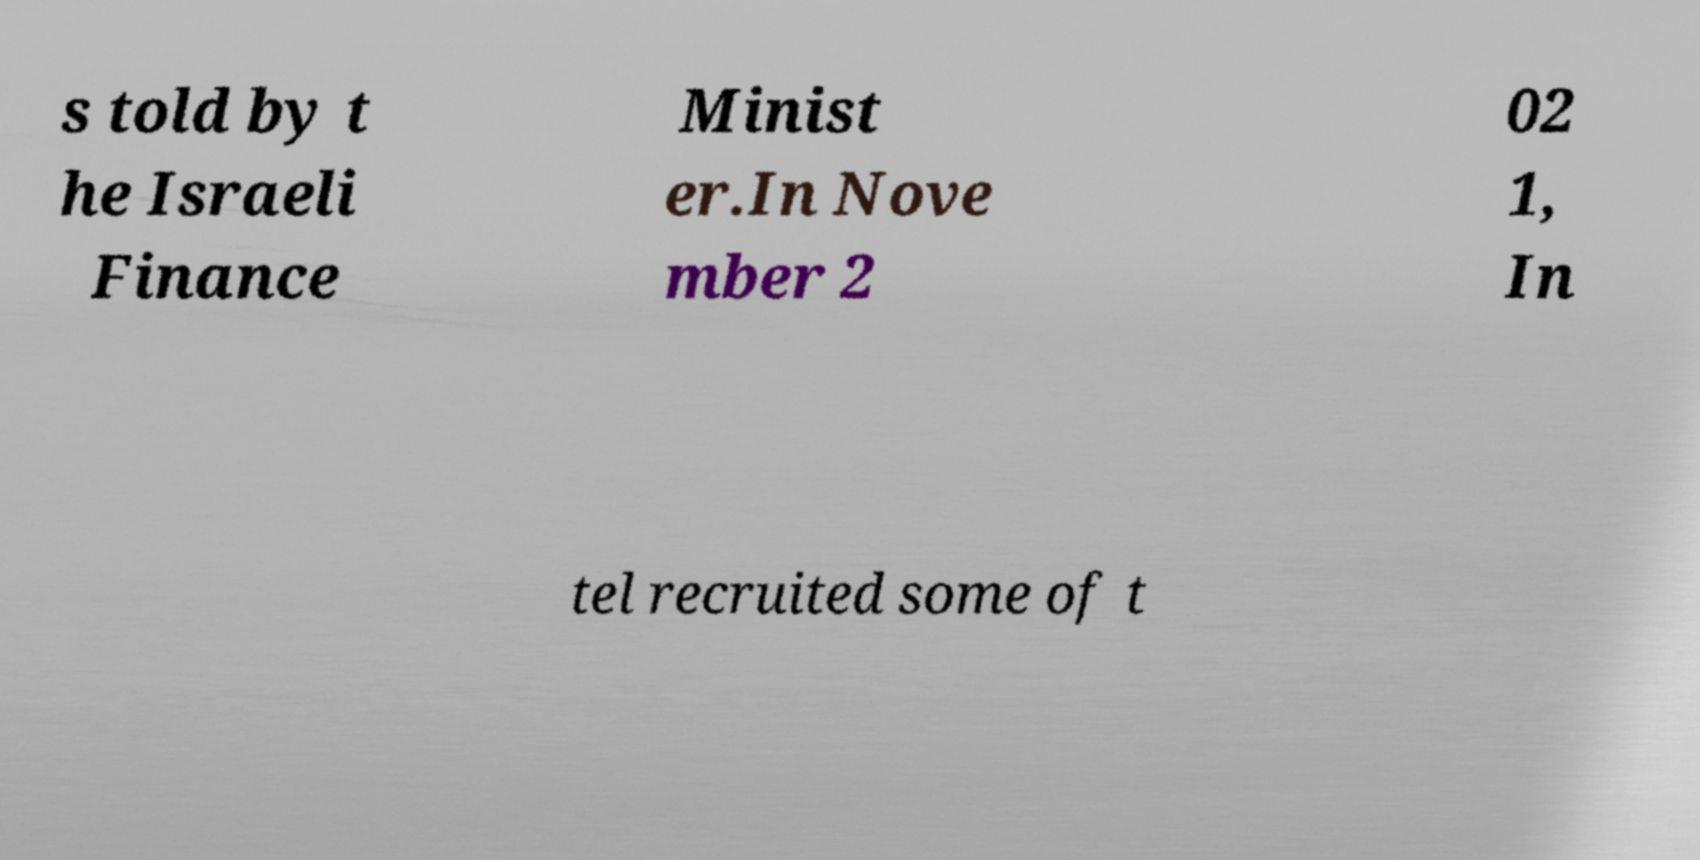Can you read and provide the text displayed in the image?This photo seems to have some interesting text. Can you extract and type it out for me? s told by t he Israeli Finance Minist er.In Nove mber 2 02 1, In tel recruited some of t 